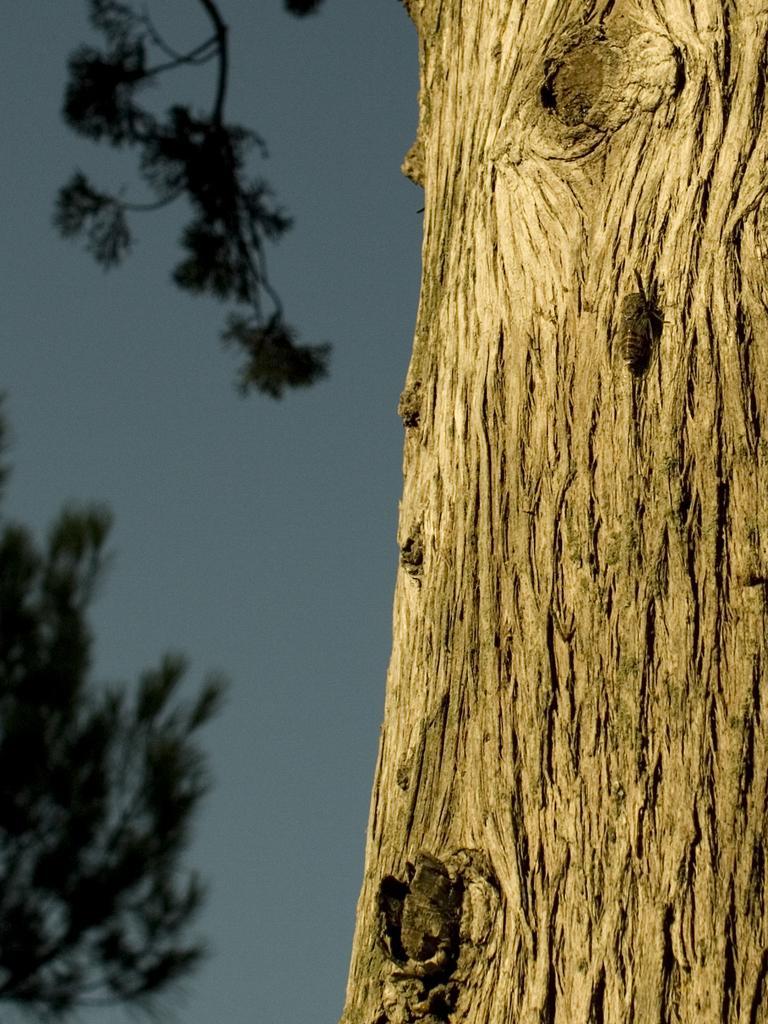Describe this image in one or two sentences. In this image there is a tree trunk. Left side there are few branches having leaves. Background there is sky. 